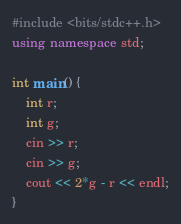Convert code to text. <code><loc_0><loc_0><loc_500><loc_500><_C++_>#include <bits/stdc++.h>
using namespace std;

int main() {
    int r;
    int g;
    cin >> r;
    cin >> g;
    cout << 2*g - r << endl;
}</code> 